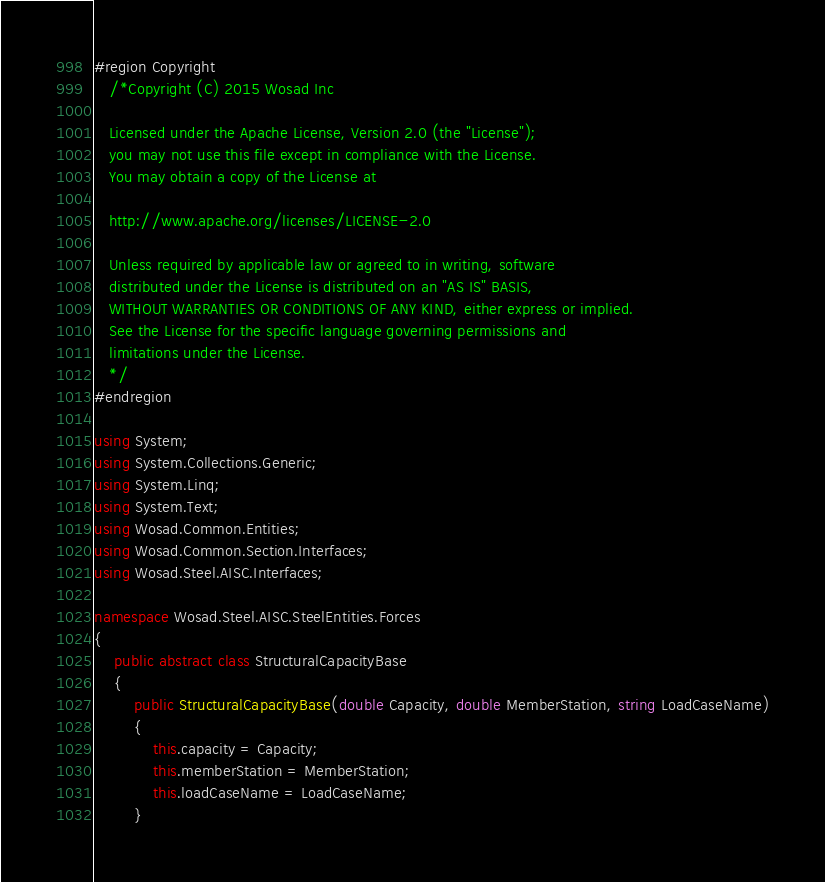Convert code to text. <code><loc_0><loc_0><loc_500><loc_500><_C#_>#region Copyright
   /*Copyright (C) 2015 Wosad Inc

   Licensed under the Apache License, Version 2.0 (the "License");
   you may not use this file except in compliance with the License.
   You may obtain a copy of the License at

   http://www.apache.org/licenses/LICENSE-2.0

   Unless required by applicable law or agreed to in writing, software
   distributed under the License is distributed on an "AS IS" BASIS,
   WITHOUT WARRANTIES OR CONDITIONS OF ANY KIND, either express or implied.
   See the License for the specific language governing permissions and
   limitations under the License.
   */
#endregion

using System;
using System.Collections.Generic;
using System.Linq;
using System.Text; using Wosad.Common.Entities; using Wosad.Common.Section.Interfaces; using Wosad.Steel.AISC.Interfaces;

namespace Wosad.Steel.AISC.SteelEntities.Forces
{
    public abstract class StructuralCapacityBase
    {
        public StructuralCapacityBase(double Capacity, double MemberStation, string LoadCaseName)
        {
            this.capacity = Capacity;
            this.memberStation = MemberStation;
            this.loadCaseName = LoadCaseName;
        }
</code> 